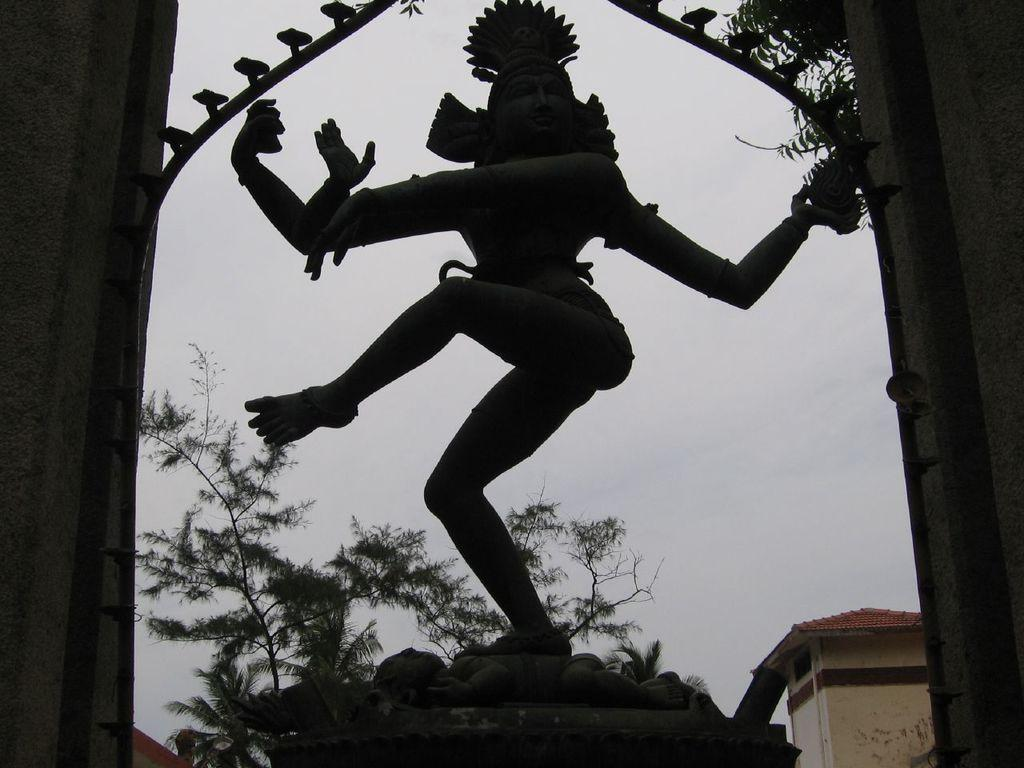What is the main subject in the image? There is a statue in the image. How is the statue positioned in the image? The statue is on a pedestal. What can be seen in the background of the image? There are walls, trees, a building, and the sky visible in the background of the image. How many babies are holding onto the statue in the image? There are no babies present in the image, and therefore no such interaction can be observed. 